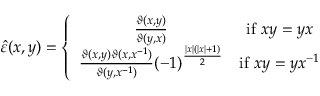<formula> <loc_0><loc_0><loc_500><loc_500>\hat { \varepsilon } ( x , y ) = \left \{ \begin{array} { c c } { { \frac { \vartheta ( x , y ) } { \vartheta ( y , x ) } } } & { i f \, x y = y x } \\ { { \frac { \vartheta ( x , y ) \vartheta ( x , x ^ { - 1 } ) } { \vartheta ( y , x ^ { - 1 } ) } ( - 1 ) ^ { \frac { \left | x \right | ( \left | x \right | + 1 ) } { 2 } } } } & { { i f \, x y = y x ^ { - 1 } } } \end{array}</formula> 